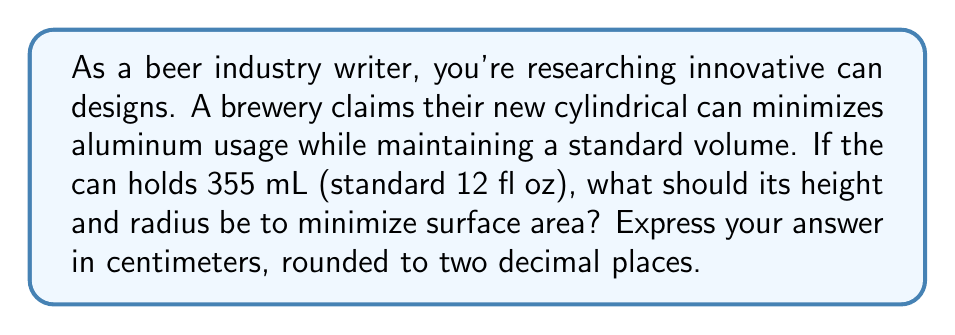Could you help me with this problem? Let's approach this step-by-step:

1) First, we need to express the surface area and volume of a cylinder in terms of its radius $r$ and height $h$:

   Surface Area: $A = 2\pi r^2 + 2\pi rh$
   Volume: $V = \pi r^2h$

2) We know the volume is fixed at 355 mL = 355 cm³. So:

   $355 = \pi r^2h$

3) We can express $h$ in terms of $r$:

   $h = \frac{355}{\pi r^2}$

4) Now, substitute this into the surface area equation:

   $A = 2\pi r^2 + 2\pi r(\frac{355}{\pi r^2})$

5) Simplify:

   $A = 2\pi r^2 + \frac{710}{r}$

6) To find the minimum, we differentiate $A$ with respect to $r$ and set it to zero:

   $\frac{dA}{dr} = 4\pi r - \frac{710}{r^2} = 0$

7) Solve this equation:

   $4\pi r^3 = 710$
   $r^3 = \frac{710}{4\pi}$
   $r = \sqrt[3]{\frac{710}{4\pi}} \approx 3.63$ cm

8) Now we can find $h$:

   $h = \frac{355}{\pi r^2} \approx 8.55$ cm

9) To verify this is a minimum, we could check the second derivative is positive at this point.
Answer: Radius ≈ 3.63 cm, Height ≈ 8.55 cm 